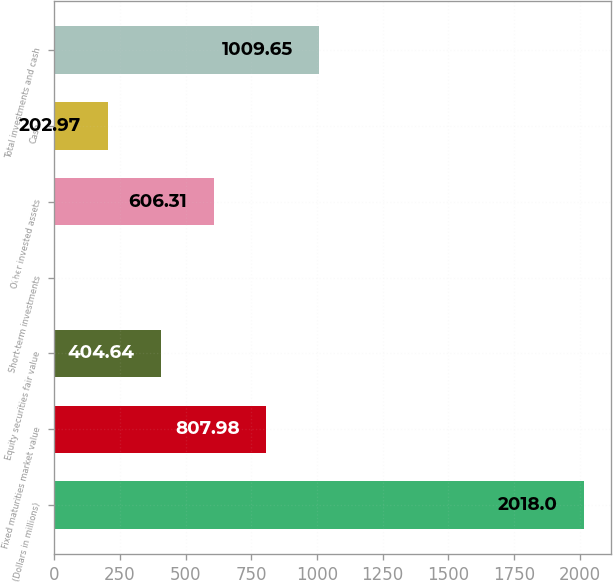Convert chart. <chart><loc_0><loc_0><loc_500><loc_500><bar_chart><fcel>(Dollars in millions)<fcel>Fixed maturities market value<fcel>Equity securities fair value<fcel>Short-term investments<fcel>Other invested assets<fcel>Cash<fcel>Total investments and cash<nl><fcel>2018<fcel>807.98<fcel>404.64<fcel>1.3<fcel>606.31<fcel>202.97<fcel>1009.65<nl></chart> 